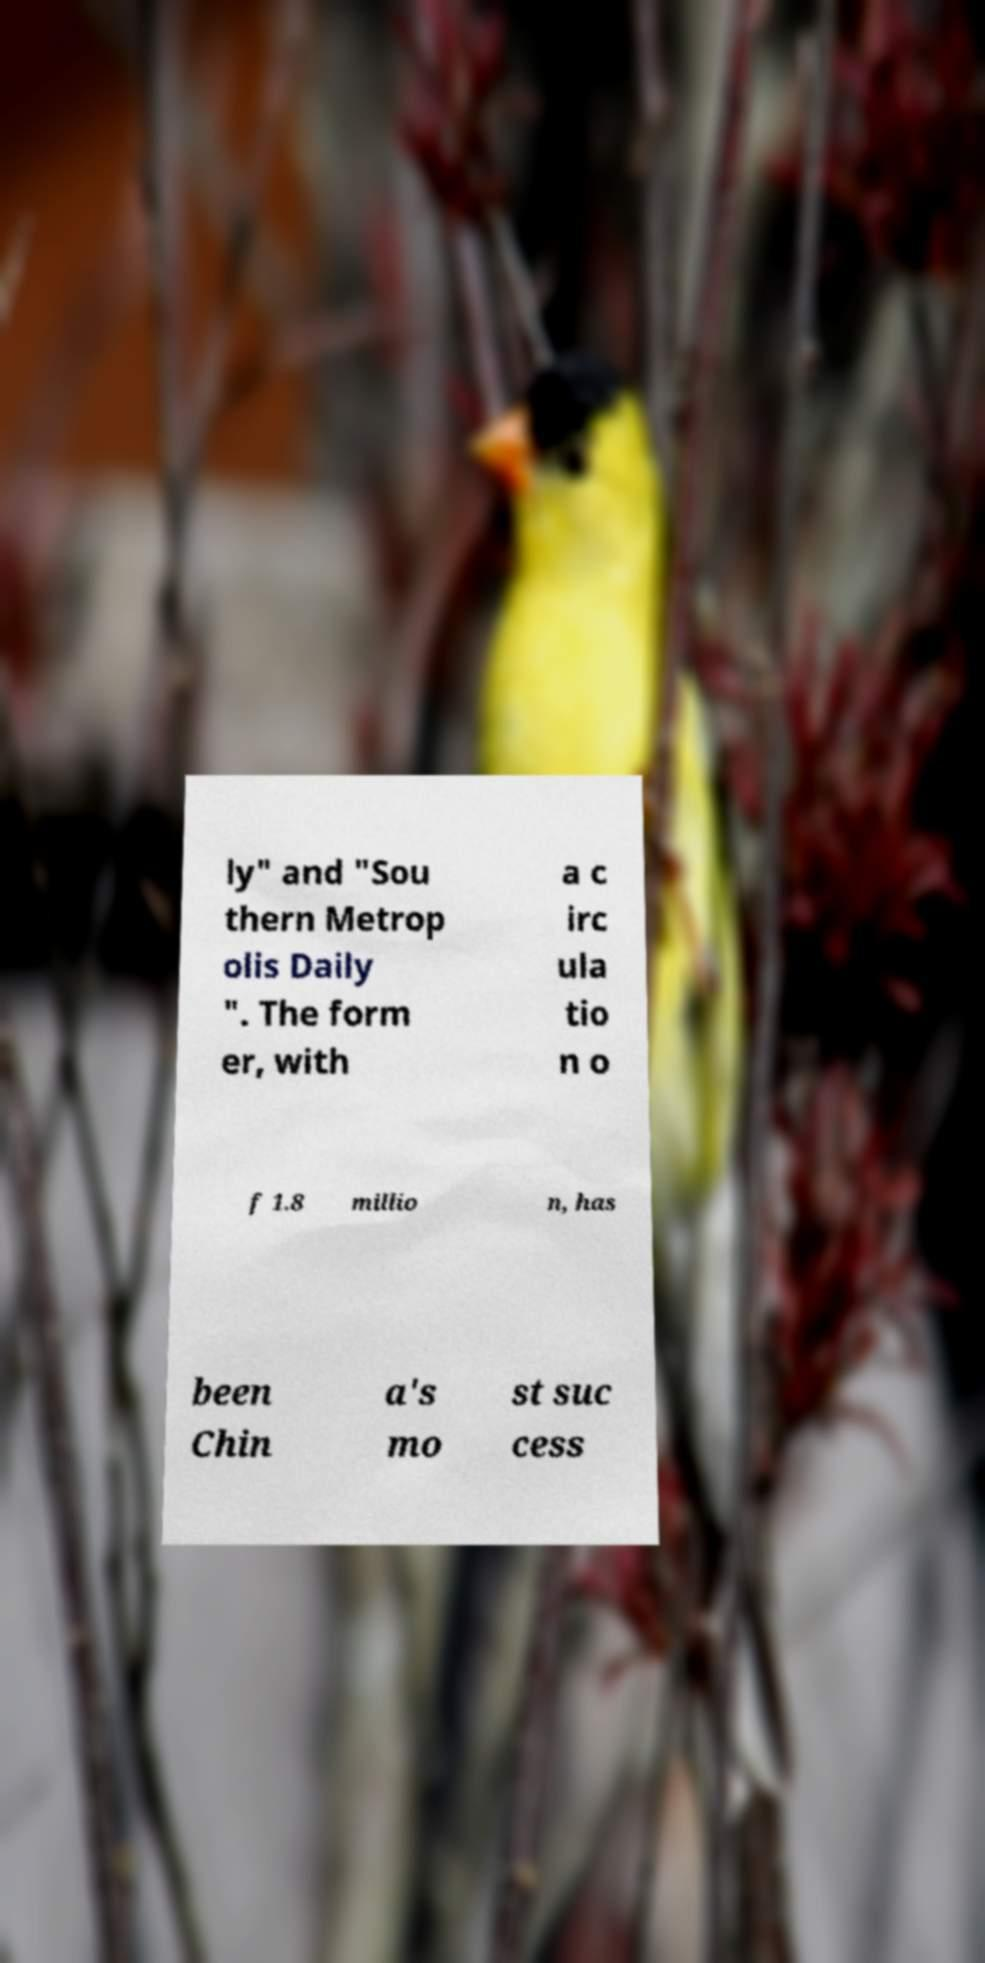Please read and relay the text visible in this image. What does it say? ly" and "Sou thern Metrop olis Daily ". The form er, with a c irc ula tio n o f 1.8 millio n, has been Chin a's mo st suc cess 